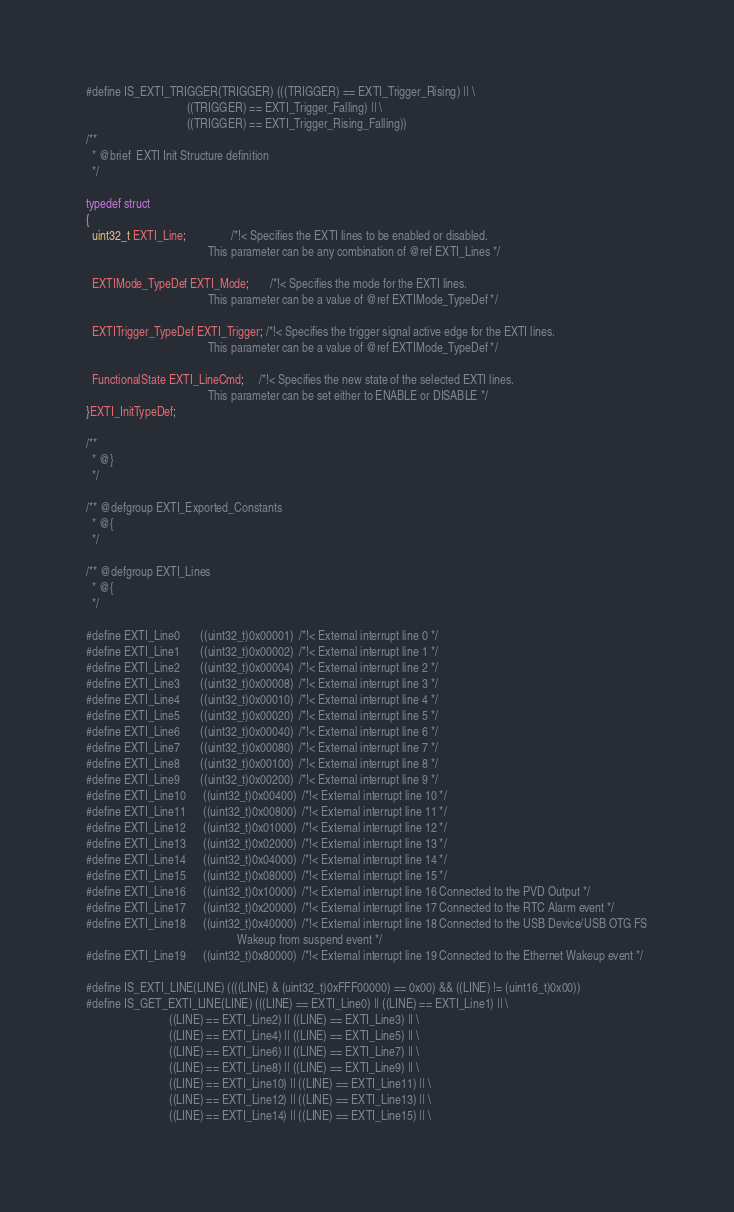<code> <loc_0><loc_0><loc_500><loc_500><_C_>
#define IS_EXTI_TRIGGER(TRIGGER) (((TRIGGER) == EXTI_Trigger_Rising) || \
                                  ((TRIGGER) == EXTI_Trigger_Falling) || \
                                  ((TRIGGER) == EXTI_Trigger_Rising_Falling))
/** 
  * @brief  EXTI Init Structure definition  
  */

typedef struct
{
  uint32_t EXTI_Line;               /*!< Specifies the EXTI lines to be enabled or disabled.
                                         This parameter can be any combination of @ref EXTI_Lines */
   
  EXTIMode_TypeDef EXTI_Mode;       /*!< Specifies the mode for the EXTI lines.
                                         This parameter can be a value of @ref EXTIMode_TypeDef */

  EXTITrigger_TypeDef EXTI_Trigger; /*!< Specifies the trigger signal active edge for the EXTI lines.
                                         This parameter can be a value of @ref EXTIMode_TypeDef */

  FunctionalState EXTI_LineCmd;     /*!< Specifies the new state of the selected EXTI lines.
                                         This parameter can be set either to ENABLE or DISABLE */ 
}EXTI_InitTypeDef;

/**
  * @}
  */

/** @defgroup EXTI_Exported_Constants
  * @{
  */

/** @defgroup EXTI_Lines 
  * @{
  */

#define EXTI_Line0       ((uint32_t)0x00001)  /*!< External interrupt line 0 */
#define EXTI_Line1       ((uint32_t)0x00002)  /*!< External interrupt line 1 */
#define EXTI_Line2       ((uint32_t)0x00004)  /*!< External interrupt line 2 */
#define EXTI_Line3       ((uint32_t)0x00008)  /*!< External interrupt line 3 */
#define EXTI_Line4       ((uint32_t)0x00010)  /*!< External interrupt line 4 */
#define EXTI_Line5       ((uint32_t)0x00020)  /*!< External interrupt line 5 */
#define EXTI_Line6       ((uint32_t)0x00040)  /*!< External interrupt line 6 */
#define EXTI_Line7       ((uint32_t)0x00080)  /*!< External interrupt line 7 */
#define EXTI_Line8       ((uint32_t)0x00100)  /*!< External interrupt line 8 */
#define EXTI_Line9       ((uint32_t)0x00200)  /*!< External interrupt line 9 */
#define EXTI_Line10      ((uint32_t)0x00400)  /*!< External interrupt line 10 */
#define EXTI_Line11      ((uint32_t)0x00800)  /*!< External interrupt line 11 */
#define EXTI_Line12      ((uint32_t)0x01000)  /*!< External interrupt line 12 */
#define EXTI_Line13      ((uint32_t)0x02000)  /*!< External interrupt line 13 */
#define EXTI_Line14      ((uint32_t)0x04000)  /*!< External interrupt line 14 */
#define EXTI_Line15      ((uint32_t)0x08000)  /*!< External interrupt line 15 */
#define EXTI_Line16      ((uint32_t)0x10000)  /*!< External interrupt line 16 Connected to the PVD Output */
#define EXTI_Line17      ((uint32_t)0x20000)  /*!< External interrupt line 17 Connected to the RTC Alarm event */
#define EXTI_Line18      ((uint32_t)0x40000)  /*!< External interrupt line 18 Connected to the USB Device/USB OTG FS
                                                   Wakeup from suspend event */                                    
#define EXTI_Line19      ((uint32_t)0x80000)  /*!< External interrupt line 19 Connected to the Ethernet Wakeup event */
                                          
#define IS_EXTI_LINE(LINE) ((((LINE) & (uint32_t)0xFFF00000) == 0x00) && ((LINE) != (uint16_t)0x00))
#define IS_GET_EXTI_LINE(LINE) (((LINE) == EXTI_Line0) || ((LINE) == EXTI_Line1) || \
                            ((LINE) == EXTI_Line2) || ((LINE) == EXTI_Line3) || \
                            ((LINE) == EXTI_Line4) || ((LINE) == EXTI_Line5) || \
                            ((LINE) == EXTI_Line6) || ((LINE) == EXTI_Line7) || \
                            ((LINE) == EXTI_Line8) || ((LINE) == EXTI_Line9) || \
                            ((LINE) == EXTI_Line10) || ((LINE) == EXTI_Line11) || \
                            ((LINE) == EXTI_Line12) || ((LINE) == EXTI_Line13) || \
                            ((LINE) == EXTI_Line14) || ((LINE) == EXTI_Line15) || \</code> 